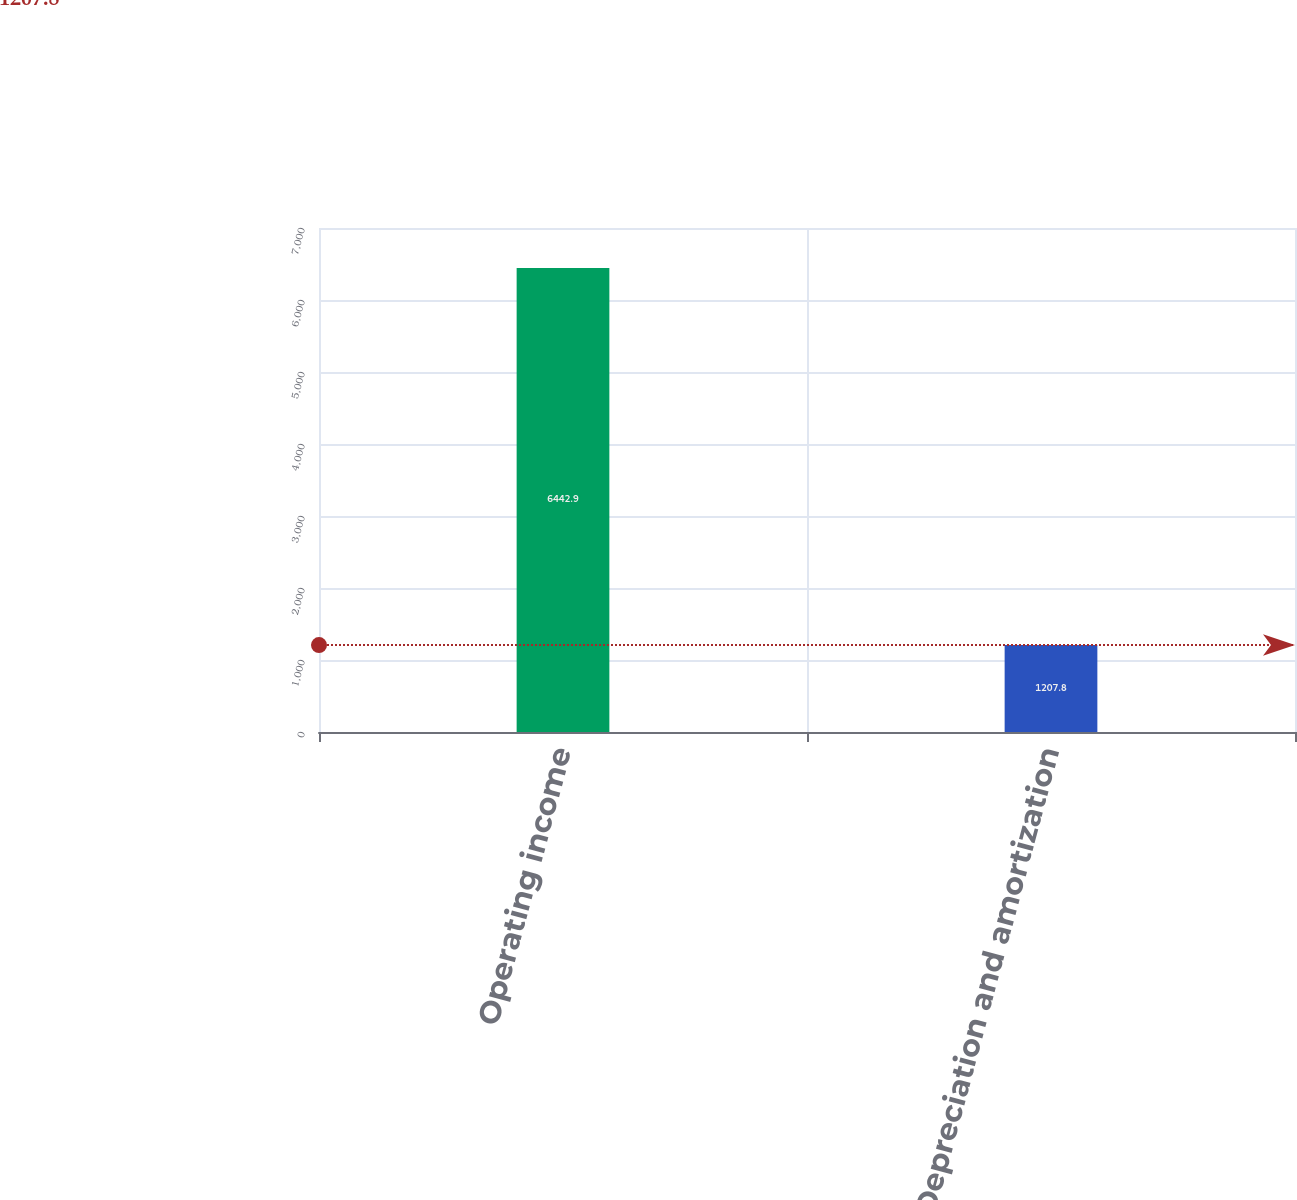Convert chart. <chart><loc_0><loc_0><loc_500><loc_500><bar_chart><fcel>Operating income<fcel>Depreciation and amortization<nl><fcel>6442.9<fcel>1207.8<nl></chart> 